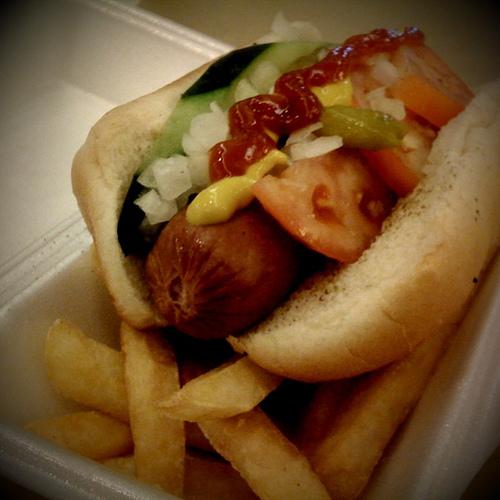Is there ketchup on the hot dog?
Answer briefly. Yes. Was the hot dog grilled?
Keep it brief. Yes. Are these curly fries?
Write a very short answer. No. How many hot dogs on the plate?
Short answer required. 1. What toppings are on the hot dog?
Short answer required. Cucumber, onion, ketchup, mustard, tomato, pepper. 